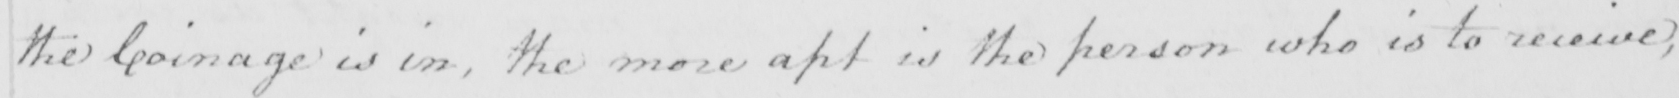What is written in this line of handwriting? the Coinage is in , the more apt is the person who is to receive , 